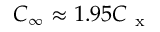<formula> <loc_0><loc_0><loc_500><loc_500>C _ { \infty } \approx 1 . 9 5 C _ { x }</formula> 